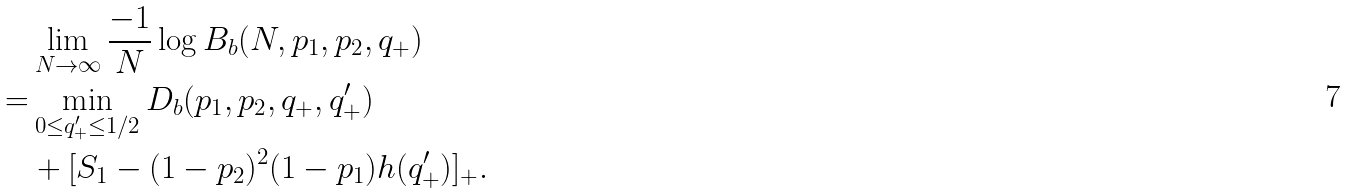<formula> <loc_0><loc_0><loc_500><loc_500>& \lim _ { N \to \infty } \frac { - 1 } { N } \log B _ { b } ( N , p _ { 1 } , p _ { 2 } , q _ { + } ) \\ = & \min _ { 0 \leq q _ { + } ^ { \prime } \leq 1 / 2 } D _ { b } ( p _ { 1 } , p _ { 2 } , q _ { + } , q _ { + } ^ { \prime } ) \\ & + [ S _ { 1 } - ( 1 - p _ { 2 } ) ^ { 2 } ( 1 - p _ { 1 } ) h ( q _ { + } ^ { \prime } ) ] _ { + } .</formula> 